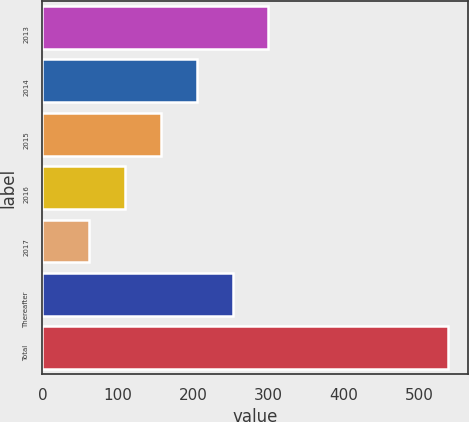Convert chart to OTSL. <chart><loc_0><loc_0><loc_500><loc_500><bar_chart><fcel>2013<fcel>2014<fcel>2015<fcel>2016<fcel>2017<fcel>Thereafter<fcel>Total<nl><fcel>300<fcel>204.8<fcel>157.2<fcel>109.6<fcel>62<fcel>252.4<fcel>538<nl></chart> 